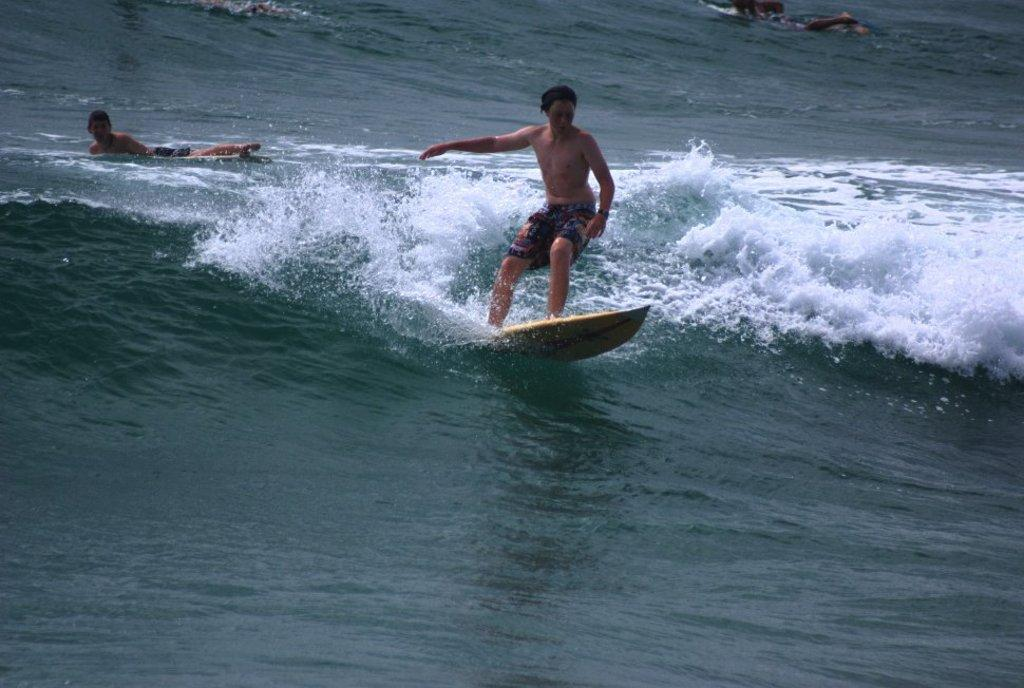What are the people in the image doing? The people in the image are swimming in the water. What activity is the man in the image participating in? The man is surfing on the water. What type of clothing is the man wearing? The man is wearing shorts. What type of string can be seen tied to the man's surfboard in the image? There is no string tied to the man's surfboard in the image. What record is being set by the people swimming in the image? There is no record being set by the people swimming in the image; they are simply swimming for leisure or exercise. 